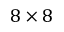<formula> <loc_0><loc_0><loc_500><loc_500>8 \times 8</formula> 